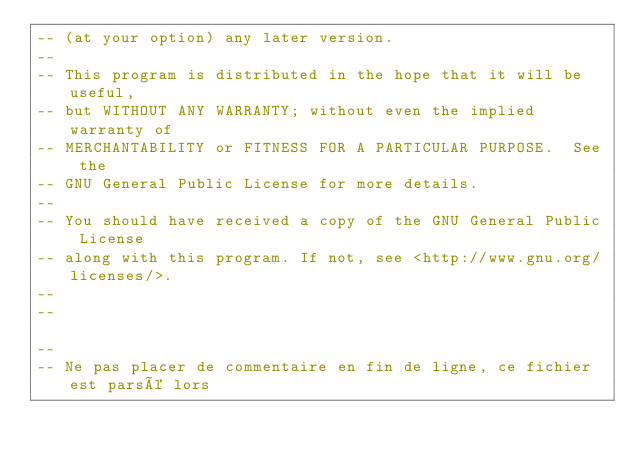Convert code to text. <code><loc_0><loc_0><loc_500><loc_500><_SQL_>-- (at your option) any later version.
--
-- This program is distributed in the hope that it will be useful,
-- but WITHOUT ANY WARRANTY; without even the implied warranty of
-- MERCHANTABILITY or FITNESS FOR A PARTICULAR PURPOSE.  See the
-- GNU General Public License for more details.
--
-- You should have received a copy of the GNU General Public License
-- along with this program. If not, see <http://www.gnu.org/licenses/>.
--
--

--
-- Ne pas placer de commentaire en fin de ligne, ce fichier est parsé lors</code> 